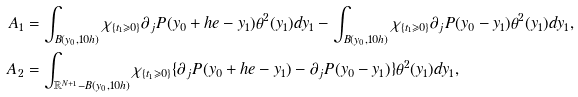<formula> <loc_0><loc_0><loc_500><loc_500>A _ { 1 } & = \int _ { B ( y _ { 0 } , 1 0 h ) } \chi _ { \{ t _ { 1 } \geqslant 0 \} } \partial _ { j } P ( y _ { 0 } + h e - y _ { 1 } ) \theta ^ { 2 } ( y _ { 1 } ) d y _ { 1 } - \int _ { B ( y _ { 0 } , 1 0 h ) } \chi _ { \{ t _ { 1 } \geqslant 0 \} } \partial _ { j } P ( y _ { 0 } - y _ { 1 } ) \theta ^ { 2 } ( y _ { 1 } ) d y _ { 1 } , \\ A _ { 2 } & = \int _ { \mathbb { R } ^ { N + 1 } - B ( y _ { 0 } , 1 0 h ) } \chi _ { \{ t _ { 1 } \geqslant 0 \} } \{ \partial _ { j } P ( y _ { 0 } + h e - y _ { 1 } ) - \partial _ { j } P ( y _ { 0 } - y _ { 1 } ) \} \theta ^ { 2 } ( y _ { 1 } ) d y _ { 1 } ,</formula> 